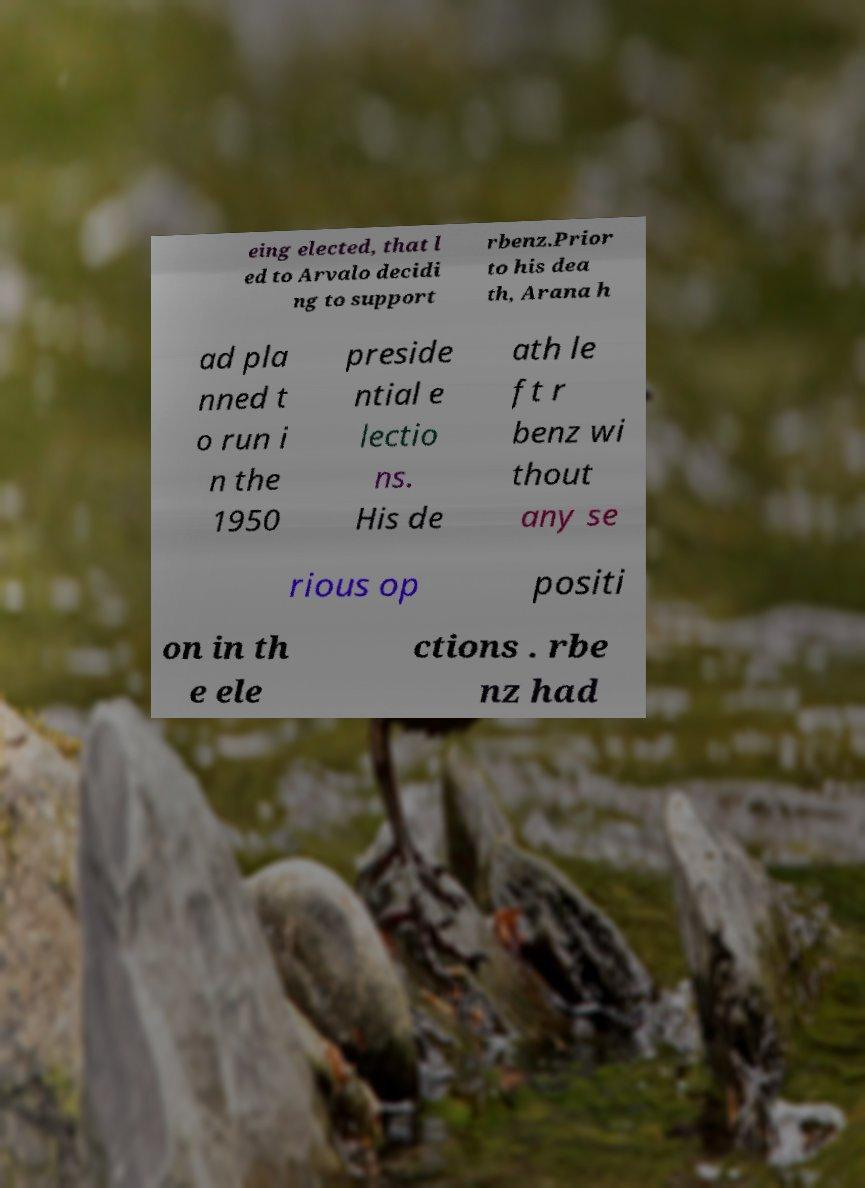I need the written content from this picture converted into text. Can you do that? eing elected, that l ed to Arvalo decidi ng to support rbenz.Prior to his dea th, Arana h ad pla nned t o run i n the 1950 preside ntial e lectio ns. His de ath le ft r benz wi thout any se rious op positi on in th e ele ctions . rbe nz had 